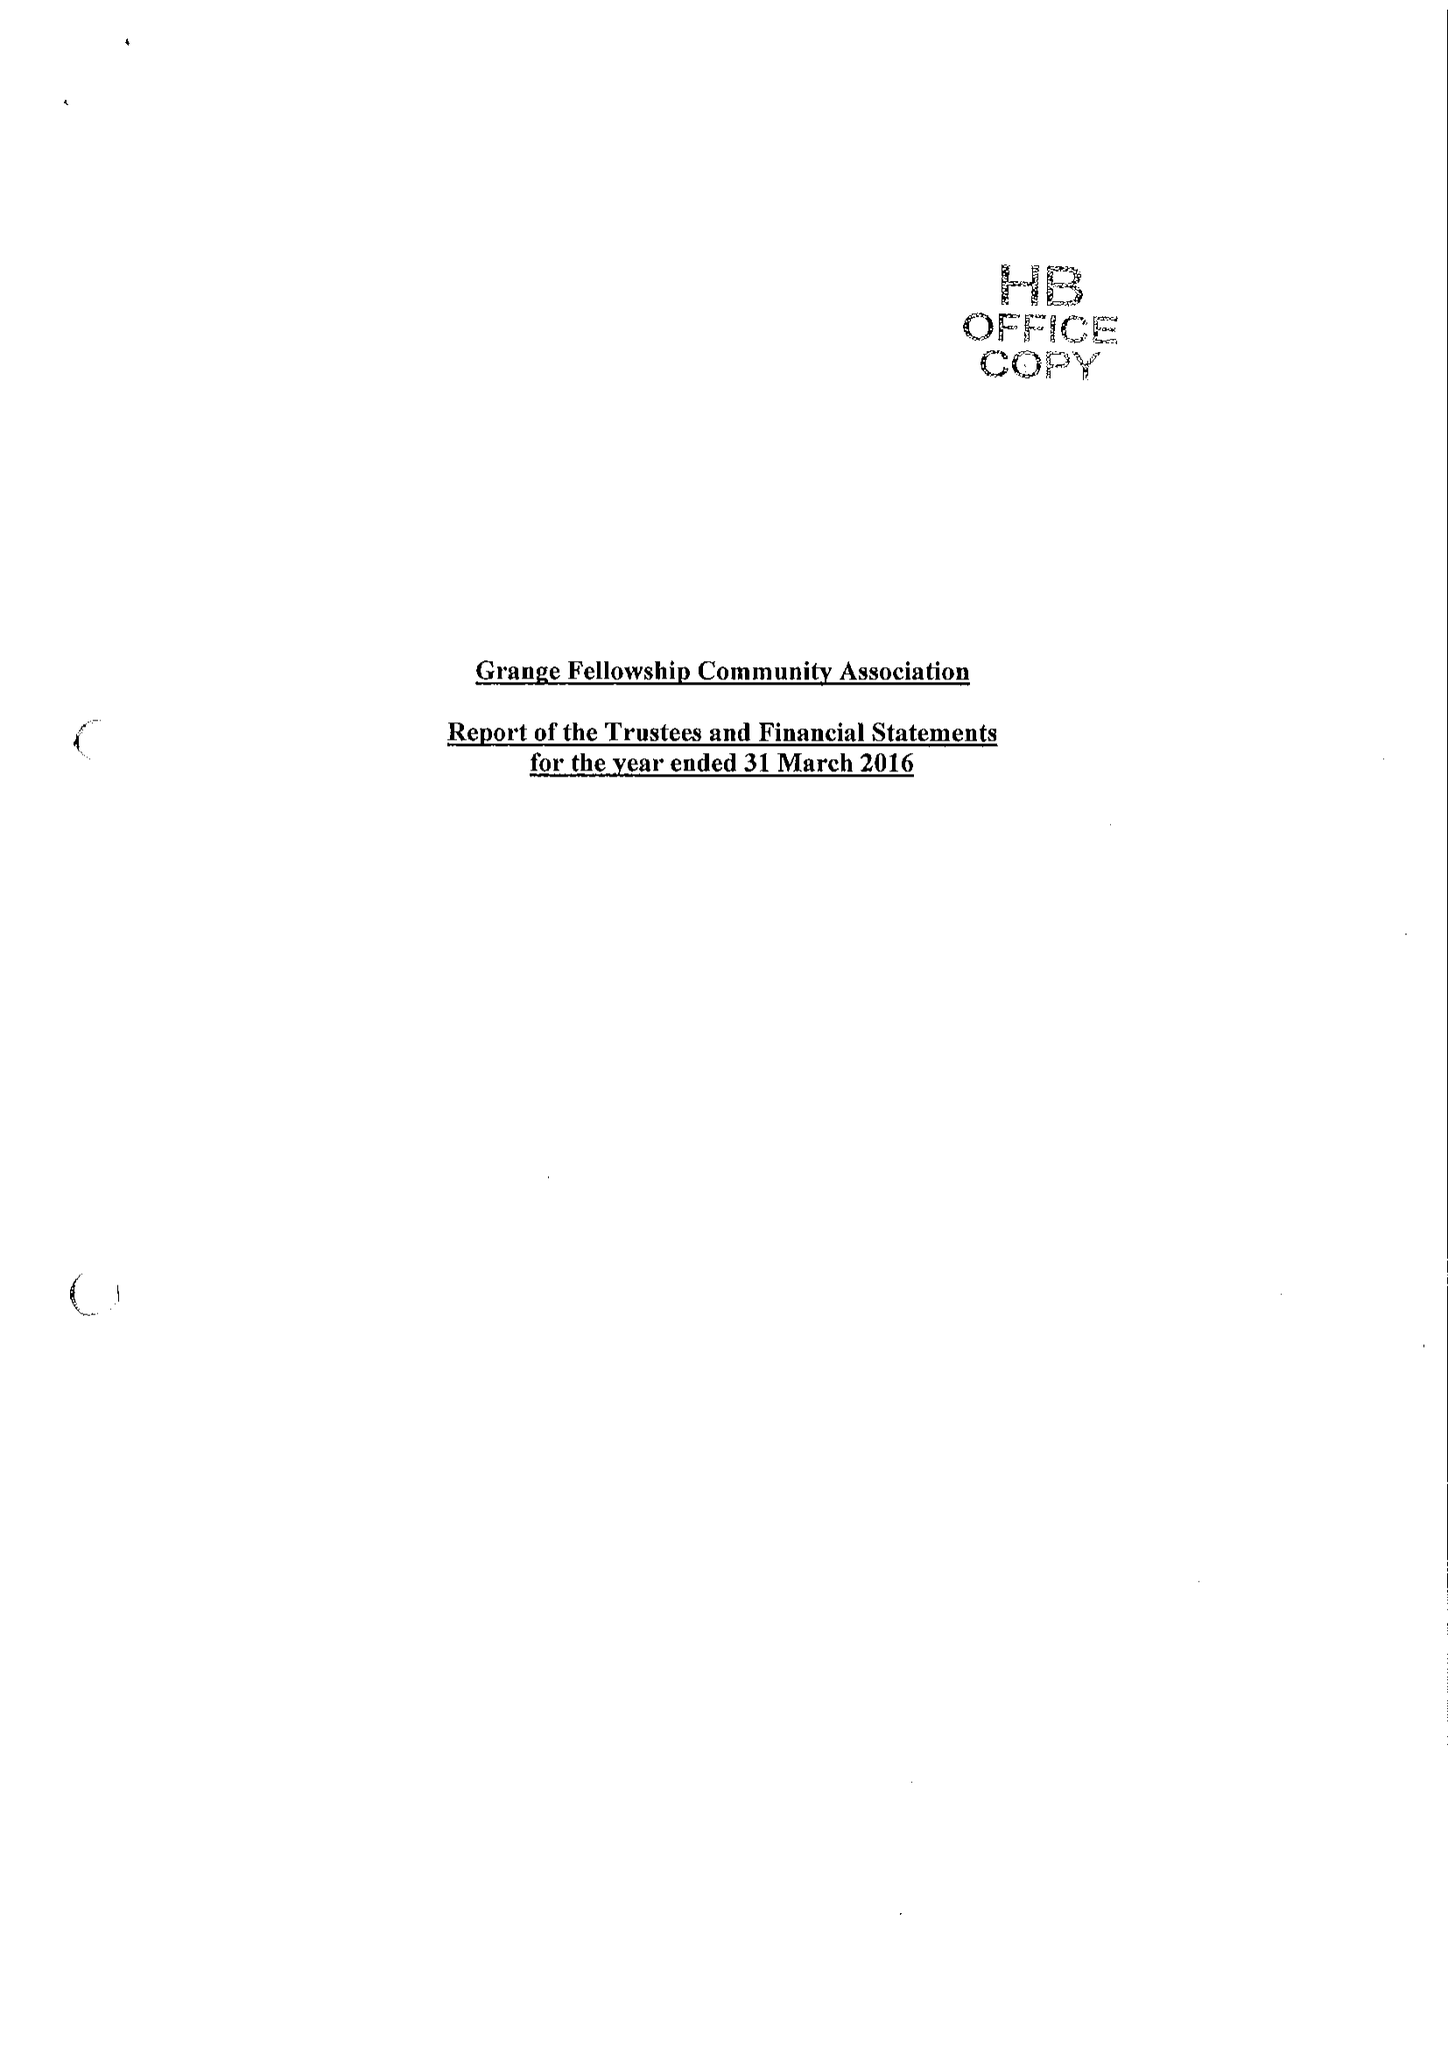What is the value for the charity_name?
Answer the question using a single word or phrase. Grange Fellowship Community Association 